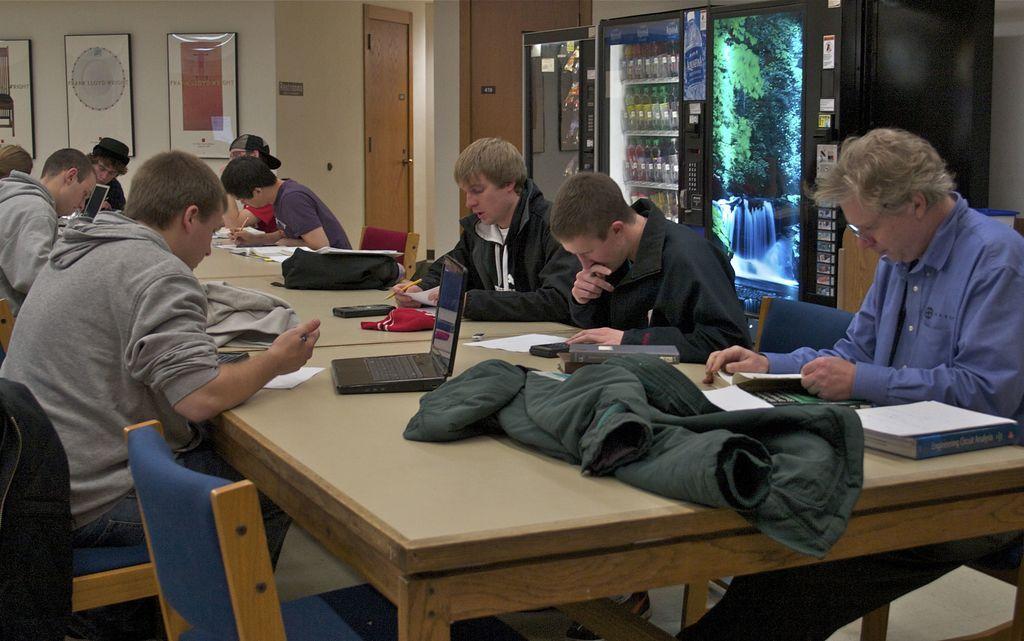How would you summarize this image in a sentence or two? In this picture there are some boys sitting on a chair. And to the right corner there is man sitting. In front of them there is a table with a jacket, laptop, mobile phone, books on it. In the background there is a fridge with water bottle in it. On the wall there are three frames. And to the corner there is a door. 